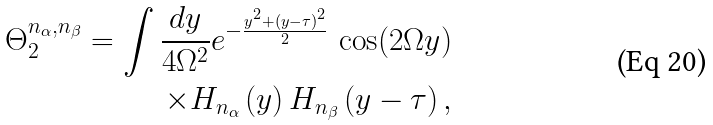<formula> <loc_0><loc_0><loc_500><loc_500>\Theta _ { 2 } ^ { n _ { \alpha } , n _ { \beta } } = \int \frac { d y } { 4 \Omega ^ { 2 } } e ^ { - \frac { y ^ { 2 } + ( y - \tau ) ^ { 2 } } { 2 } } \, \cos ( 2 \Omega y ) \\ \times H _ { n _ { \alpha } } \left ( y \right ) H _ { n _ { \beta } } \left ( y - \tau \right ) ,</formula> 